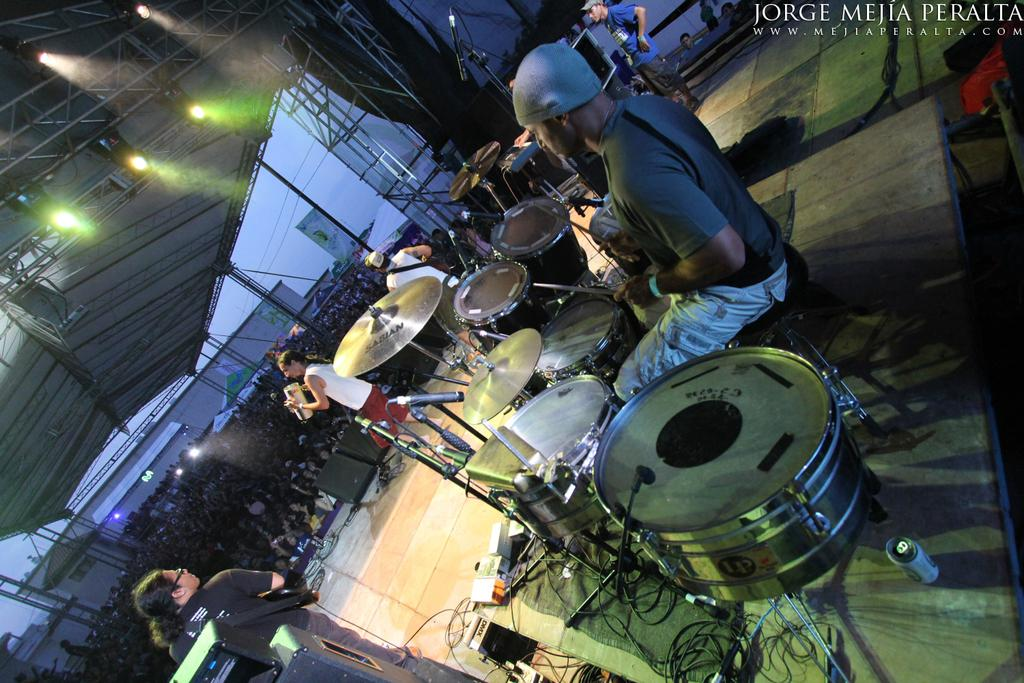What is the person in the image doing? The person is sitting and holding sticks, drums, and cymbals. How are the cymbals positioned in the image? The cymbals are attached to cymbal stands. How many people are standing in the image? There are four persons standing in the image. Can you describe the group of people in the image? There is a group of people, including the person sitting and the four standing persons. What can be seen in the background of the image? There is a lighting truss and focus lights in the image. What type of popcorn is being served to the audience in the image? There is no popcorn present in the image. What disease is affecting the person sitting in the image? There is no indication of any disease affecting the person in the image. 